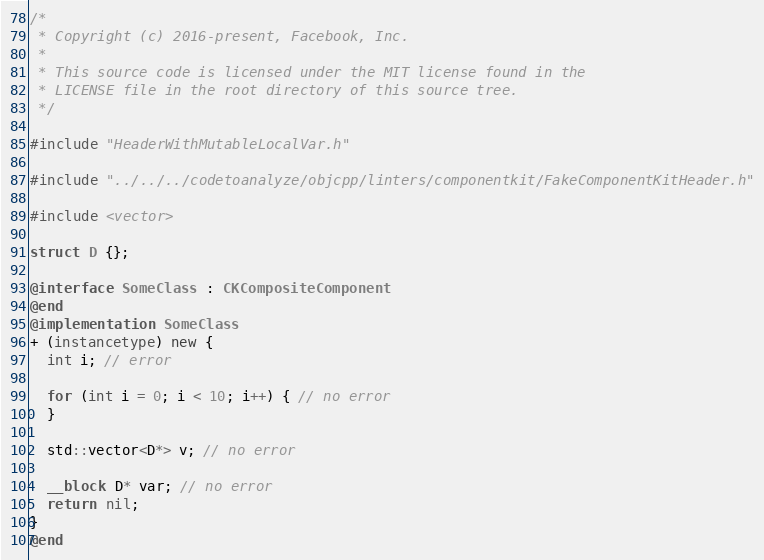Convert code to text. <code><loc_0><loc_0><loc_500><loc_500><_ObjectiveC_>/*
 * Copyright (c) 2016-present, Facebook, Inc.
 *
 * This source code is licensed under the MIT license found in the
 * LICENSE file in the root directory of this source tree.
 */

#include "HeaderWithMutableLocalVar.h"

#include "../../../codetoanalyze/objcpp/linters/componentkit/FakeComponentKitHeader.h"

#include <vector>

struct D {};

@interface SomeClass : CKCompositeComponent
@end
@implementation SomeClass
+ (instancetype) new {
  int i; // error

  for (int i = 0; i < 10; i++) { // no error
  }

  std::vector<D*> v; // no error

  __block D* var; // no error
  return nil;
}
@end
</code> 